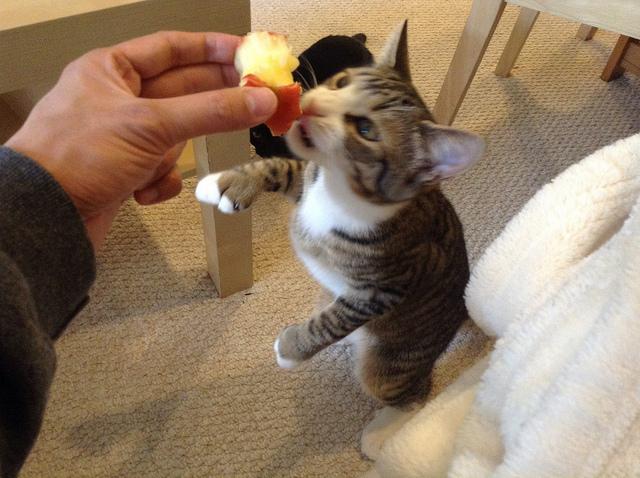What is the person feeding the cat?
Quick response, please. Apple. Why is the person feeding the kitten this way?
Be succinct. Cute. Is the cat standing on two legs?
Short answer required. Yes. What is the cat being fed?
Keep it brief. Apple. 